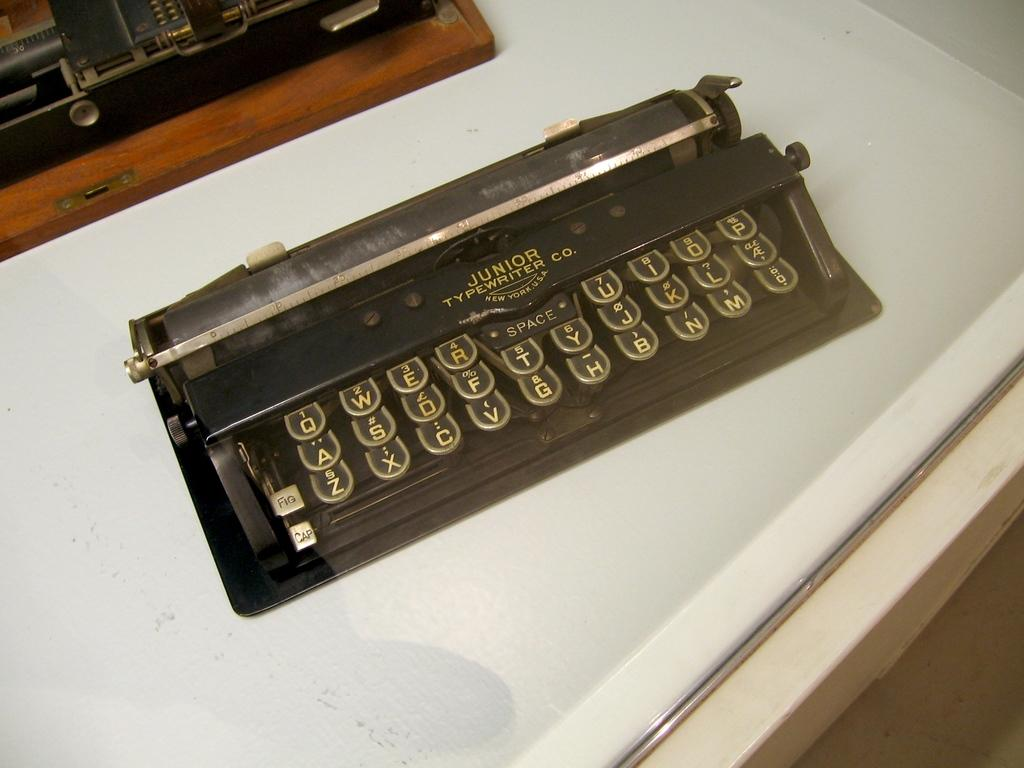Provide a one-sentence caption for the provided image. a junior brand typewriten in black with gold letters. 